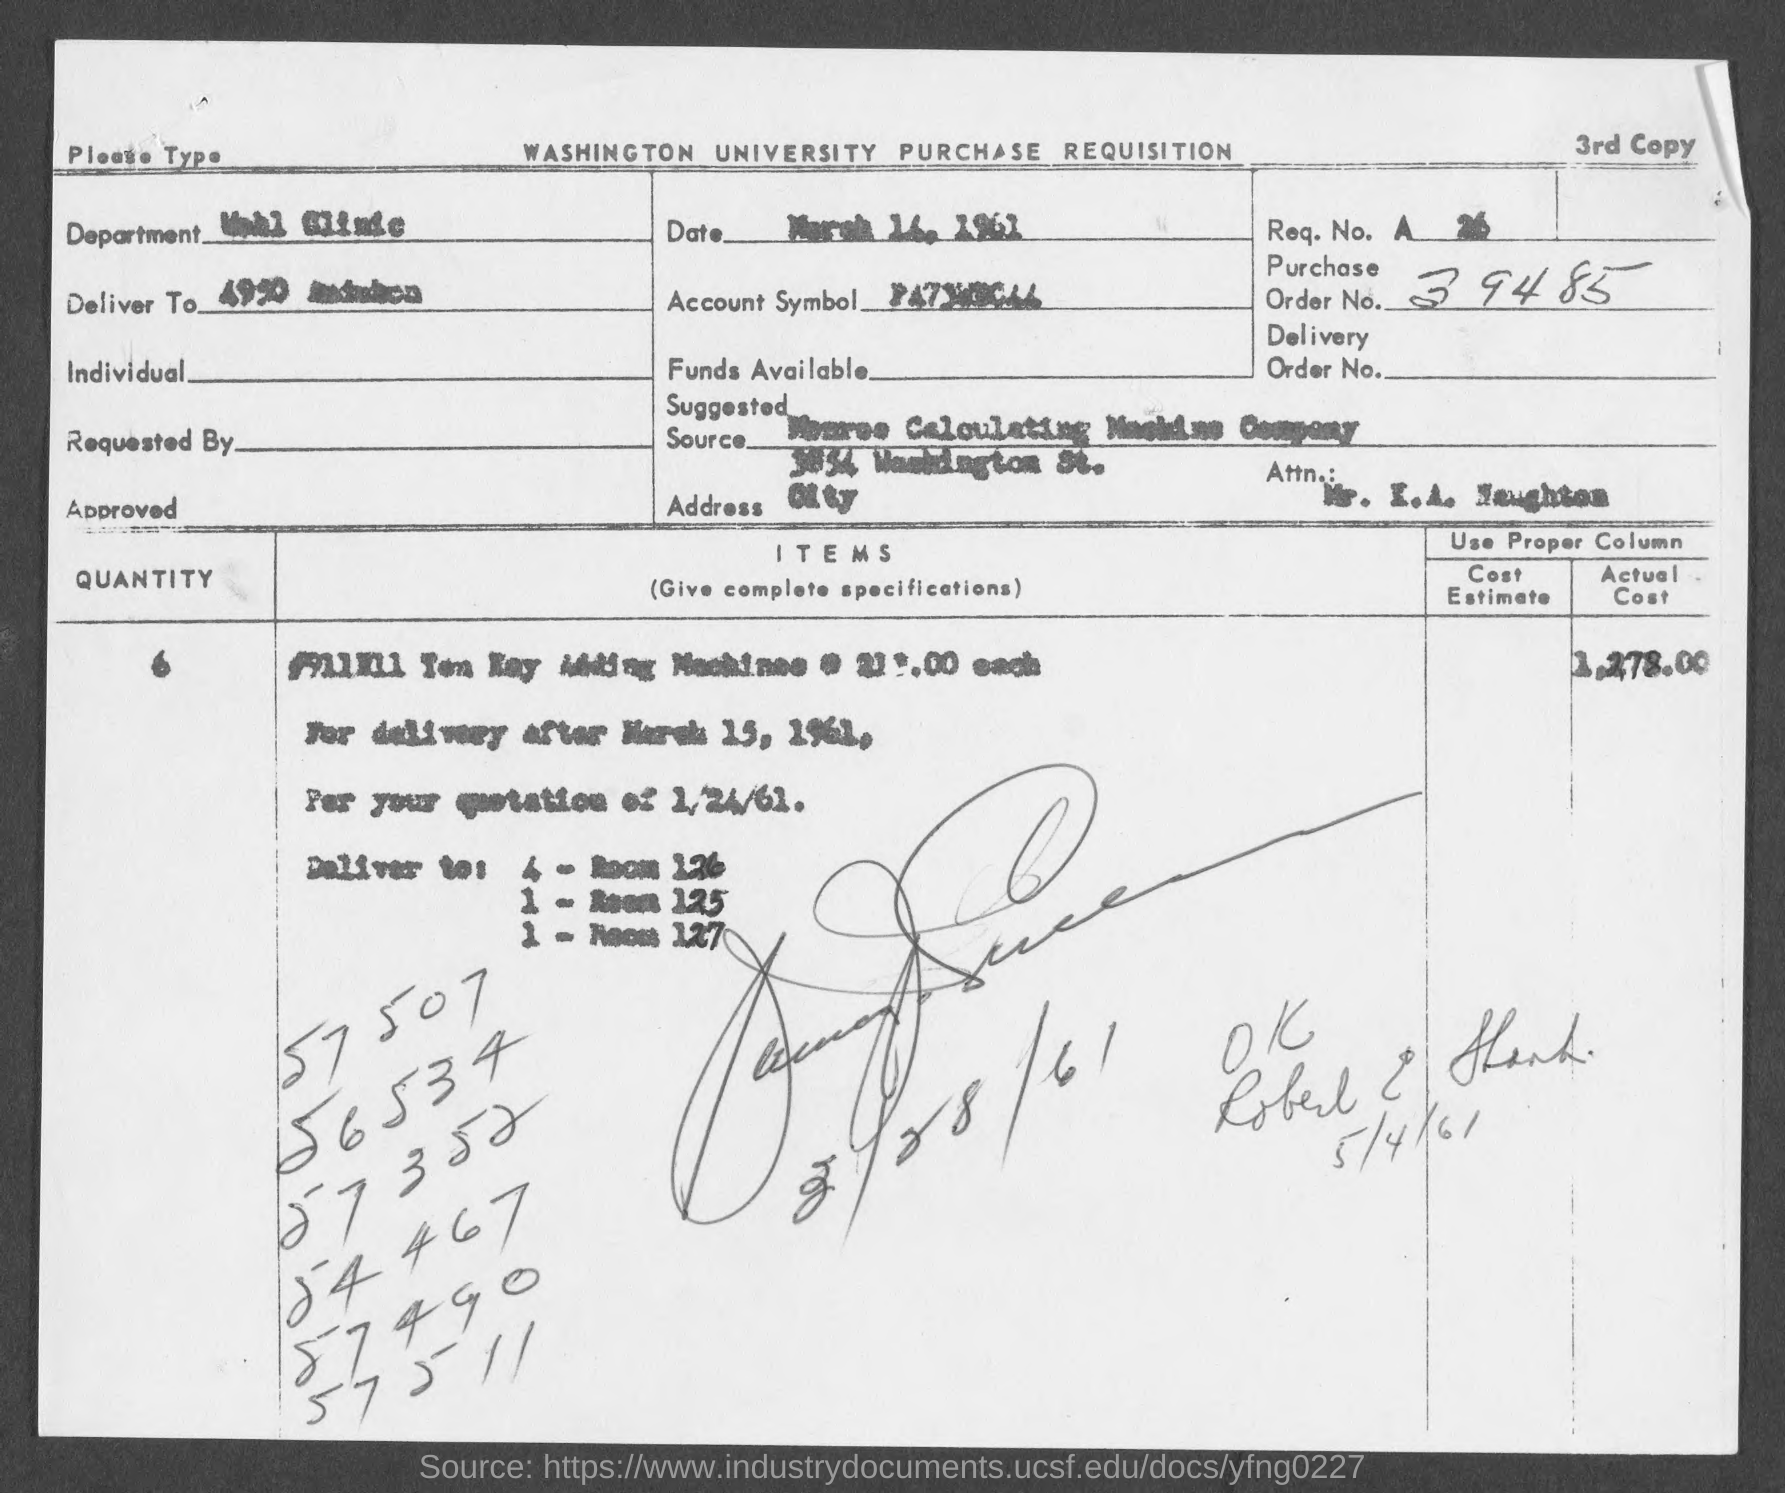What is the purchase order no.?
Offer a terse response. 39485. 